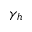<formula> <loc_0><loc_0><loc_500><loc_500>\gamma _ { h }</formula> 